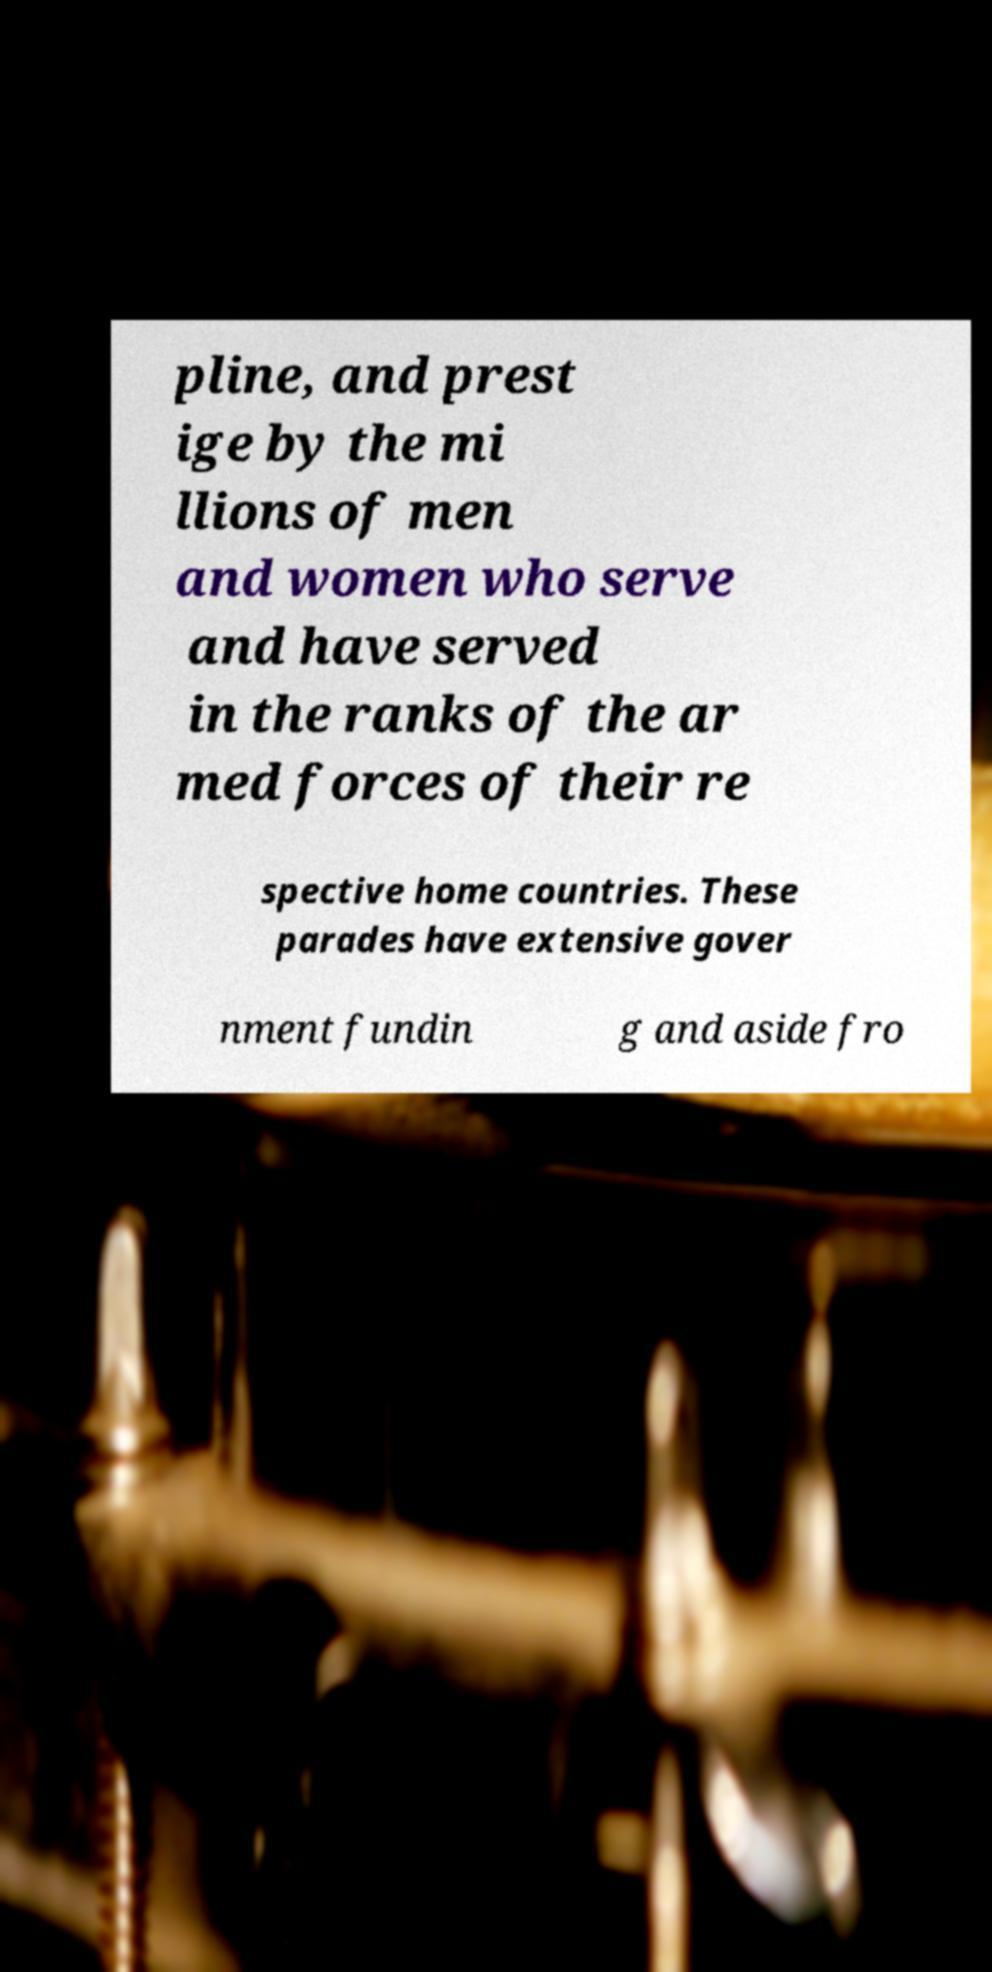There's text embedded in this image that I need extracted. Can you transcribe it verbatim? pline, and prest ige by the mi llions of men and women who serve and have served in the ranks of the ar med forces of their re spective home countries. These parades have extensive gover nment fundin g and aside fro 